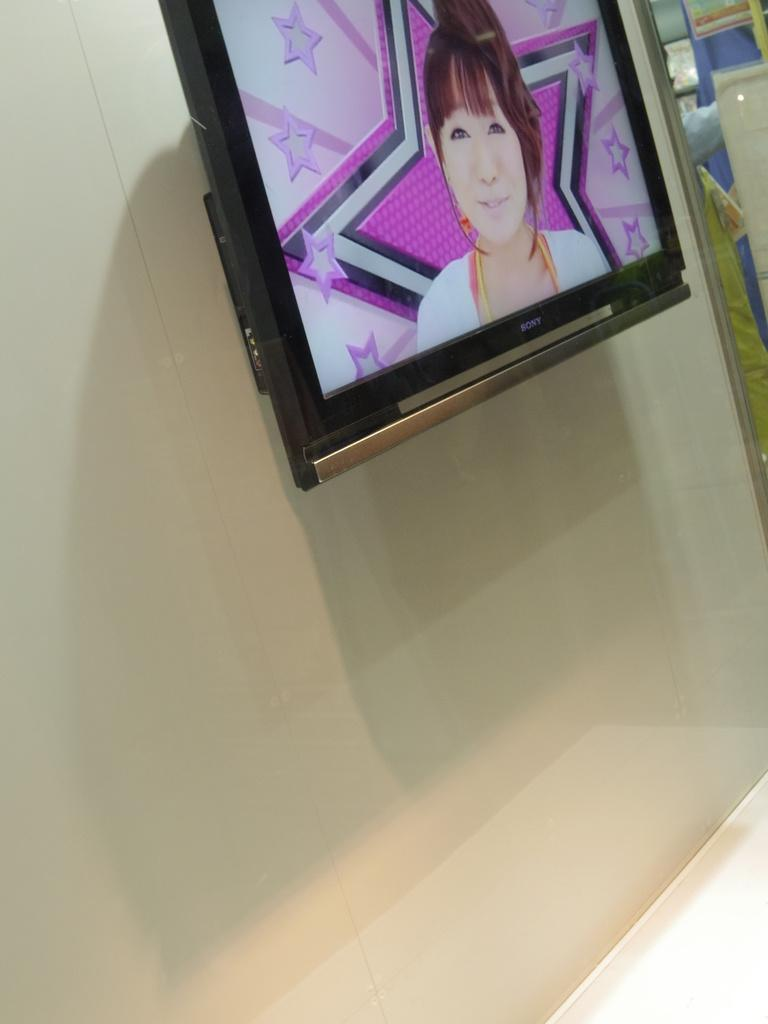What type of electronic device is on the wall in the image? There is a television on the wall in the image. Can you describe what is visible in the background of the image? There are objects visible in the background of the image. How does the television push its friend in the image? There is no television pushing a friend in the image, as televisions are inanimate objects and cannot push or interact with other objects or people. 